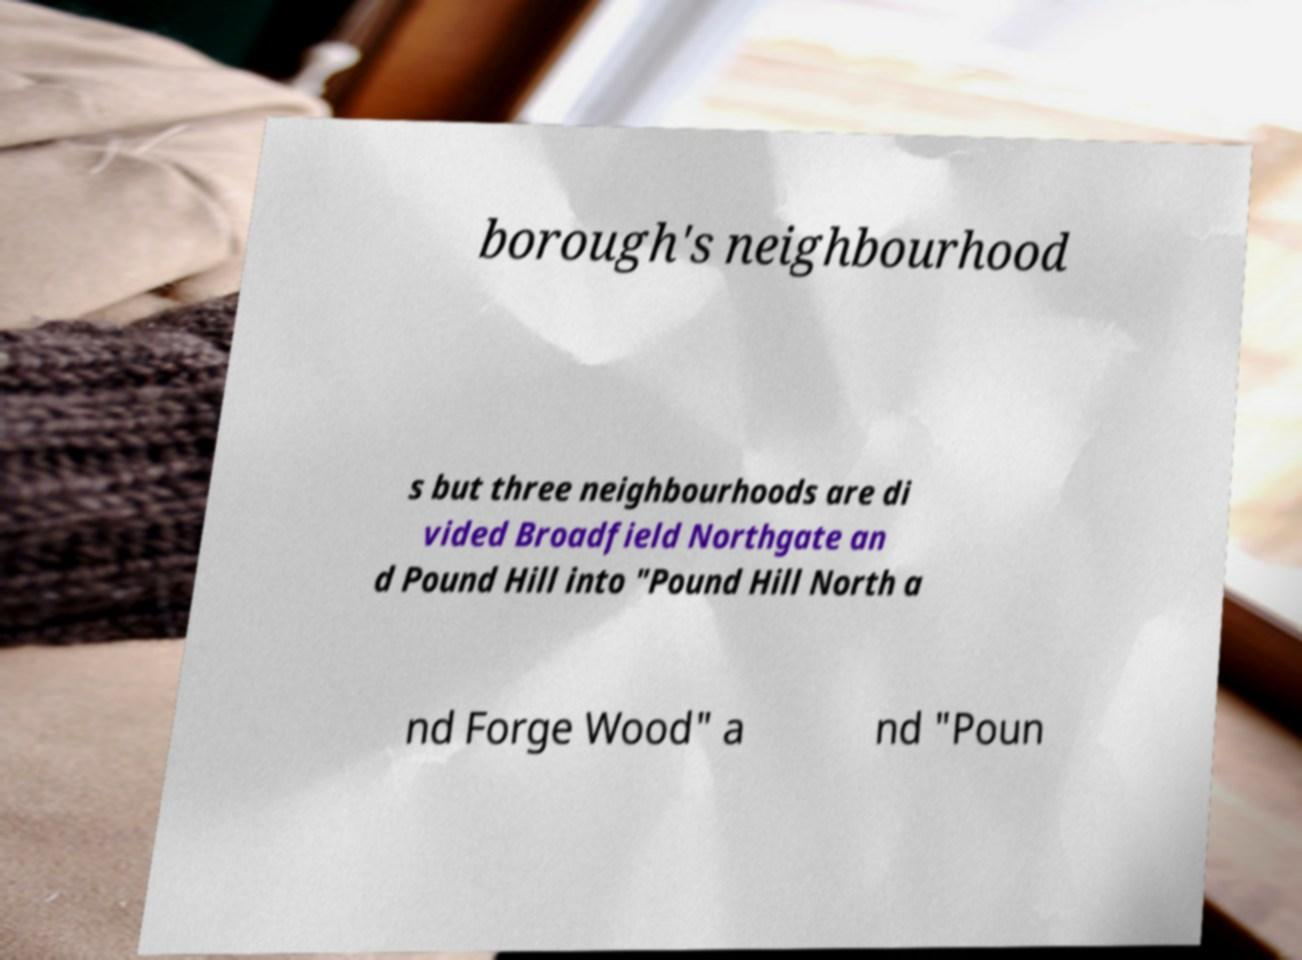For documentation purposes, I need the text within this image transcribed. Could you provide that? borough's neighbourhood s but three neighbourhoods are di vided Broadfield Northgate an d Pound Hill into "Pound Hill North a nd Forge Wood" a nd "Poun 